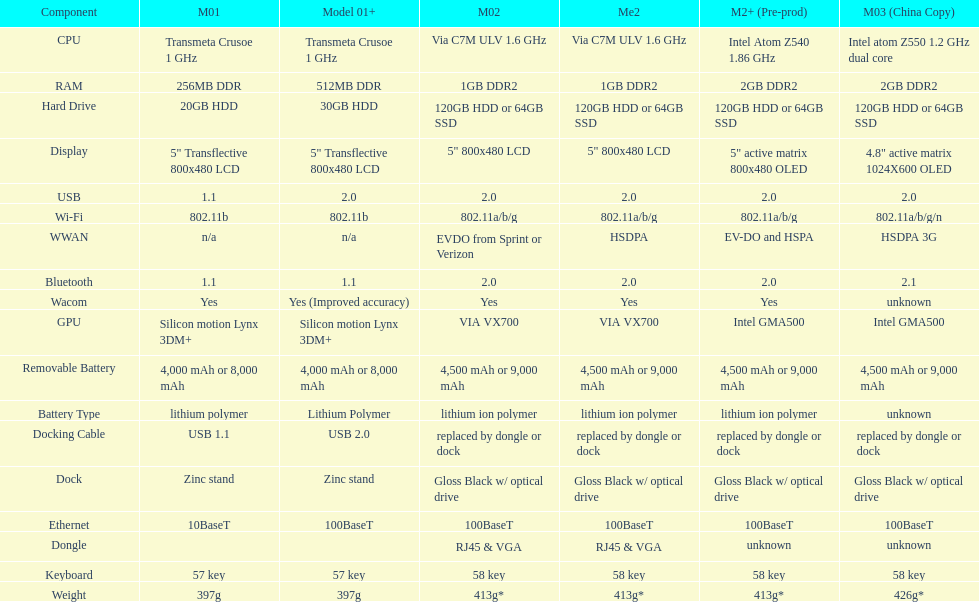The model 2 and the model 2e have what type of cpu? Via C7M ULV 1.6 GHz. 